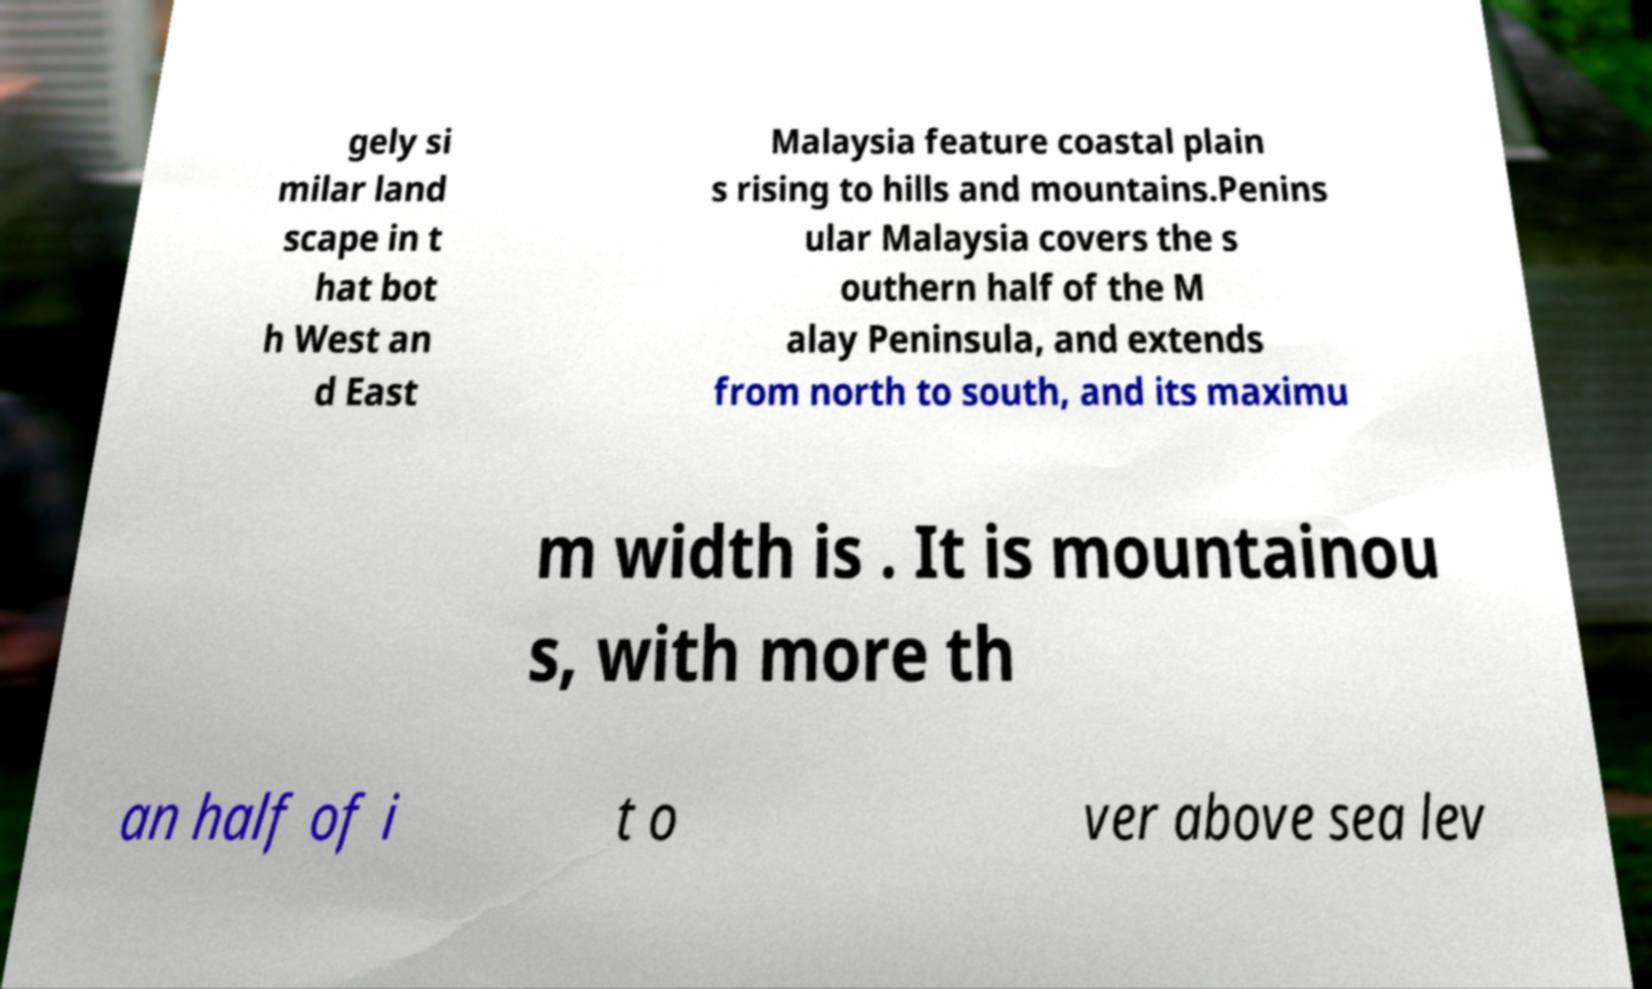For documentation purposes, I need the text within this image transcribed. Could you provide that? gely si milar land scape in t hat bot h West an d East Malaysia feature coastal plain s rising to hills and mountains.Penins ular Malaysia covers the s outhern half of the M alay Peninsula, and extends from north to south, and its maximu m width is . It is mountainou s, with more th an half of i t o ver above sea lev 